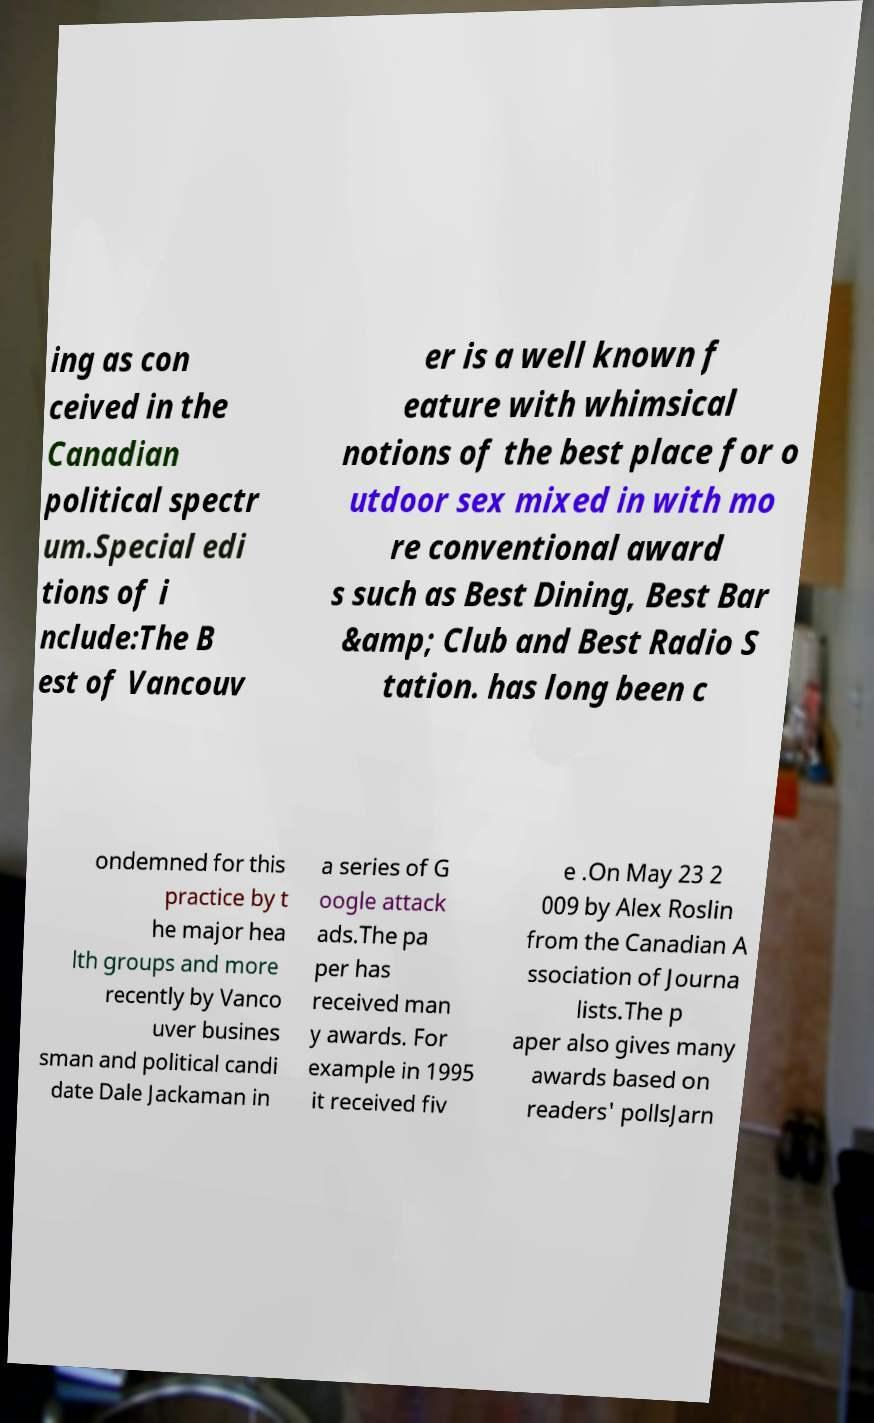Please read and relay the text visible in this image. What does it say? ing as con ceived in the Canadian political spectr um.Special edi tions of i nclude:The B est of Vancouv er is a well known f eature with whimsical notions of the best place for o utdoor sex mixed in with mo re conventional award s such as Best Dining, Best Bar &amp; Club and Best Radio S tation. has long been c ondemned for this practice by t he major hea lth groups and more recently by Vanco uver busines sman and political candi date Dale Jackaman in a series of G oogle attack ads.The pa per has received man y awards. For example in 1995 it received fiv e .On May 23 2 009 by Alex Roslin from the Canadian A ssociation of Journa lists.The p aper also gives many awards based on readers' pollsJarn 